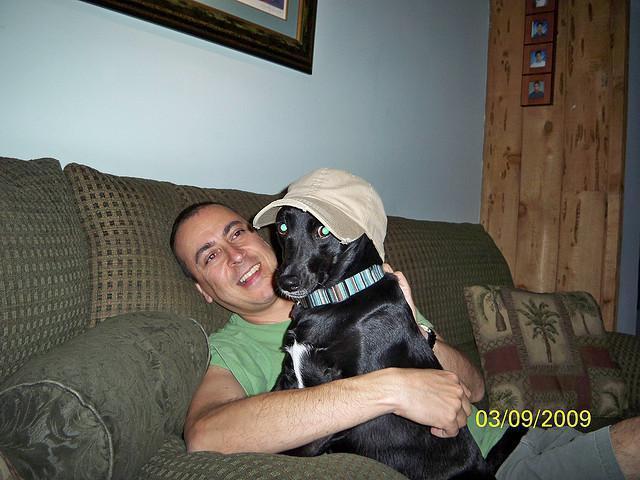How many people are visible?
Give a very brief answer. 1. 